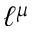Convert formula to latex. <formula><loc_0><loc_0><loc_500><loc_500>\ell ^ { \mu }</formula> 